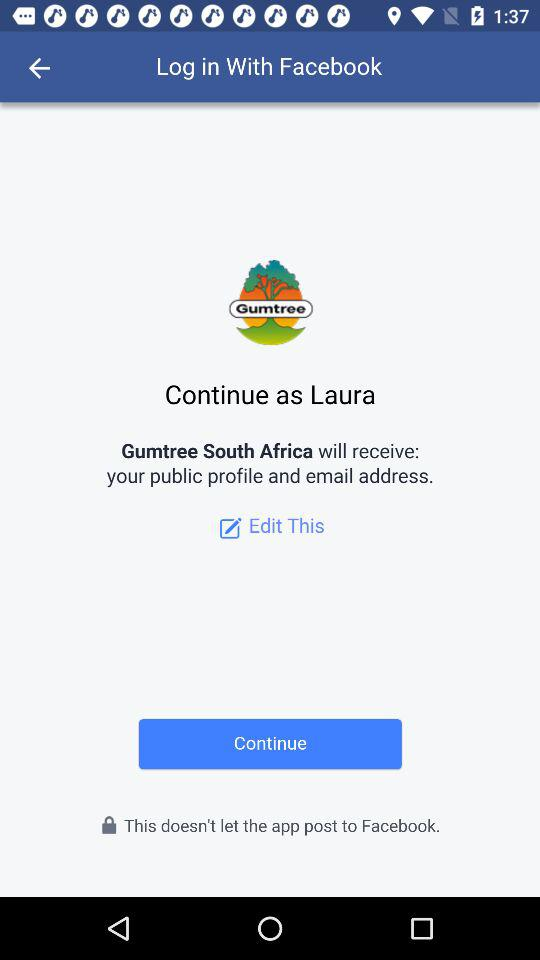Through what application can we log in? You can login through "Facebook". 